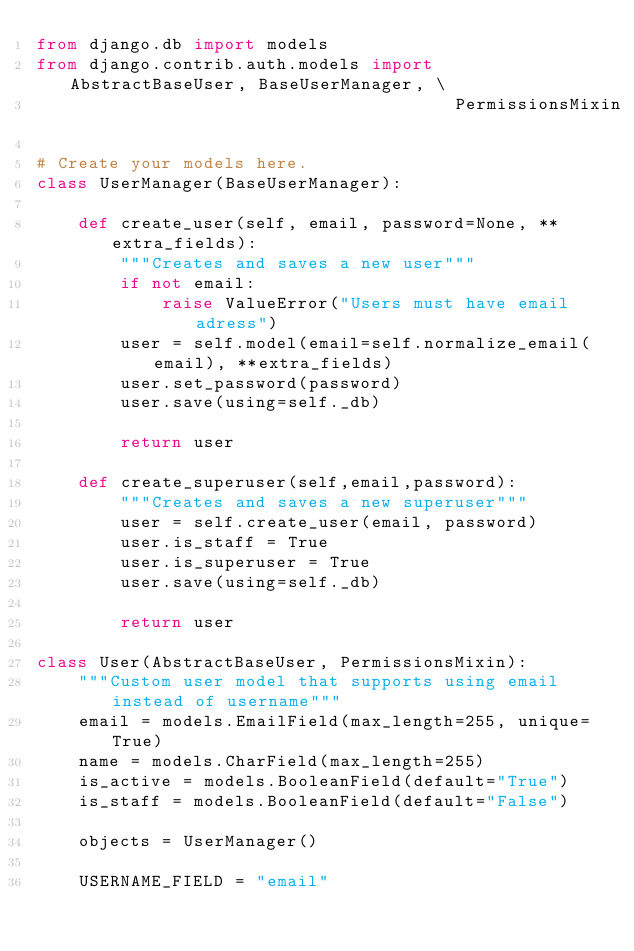Convert code to text. <code><loc_0><loc_0><loc_500><loc_500><_Python_>from django.db import models
from django.contrib.auth.models import AbstractBaseUser, BaseUserManager, \
                                        PermissionsMixin

# Create your models here.
class UserManager(BaseUserManager):

    def create_user(self, email, password=None, **extra_fields):
        """Creates and saves a new user"""
        if not email:
            raise ValueError("Users must have email adress")
        user = self.model(email=self.normalize_email(email), **extra_fields)
        user.set_password(password)
        user.save(using=self._db)

        return user

    def create_superuser(self,email,password):
        """Creates and saves a new superuser"""
        user = self.create_user(email, password)
        user.is_staff = True
        user.is_superuser = True
        user.save(using=self._db)

        return user

class User(AbstractBaseUser, PermissionsMixin):
    """Custom user model that supports using email instead of username"""
    email = models.EmailField(max_length=255, unique=True)
    name = models.CharField(max_length=255)
    is_active = models.BooleanField(default="True")
    is_staff = models.BooleanField(default="False")

    objects = UserManager()

    USERNAME_FIELD = "email"
    </code> 